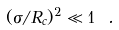<formula> <loc_0><loc_0><loc_500><loc_500>( \sigma / R _ { c } ) ^ { 2 } \ll 1 \ .</formula> 